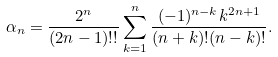Convert formula to latex. <formula><loc_0><loc_0><loc_500><loc_500>\alpha _ { n } = \frac { 2 ^ { n } } { ( 2 n - 1 ) ! ! } \sum _ { k = 1 } ^ { n } \frac { ( - 1 ) ^ { n - k } k ^ { 2 n + 1 } } { ( n + k ) ! ( n - k ) ! } .</formula> 